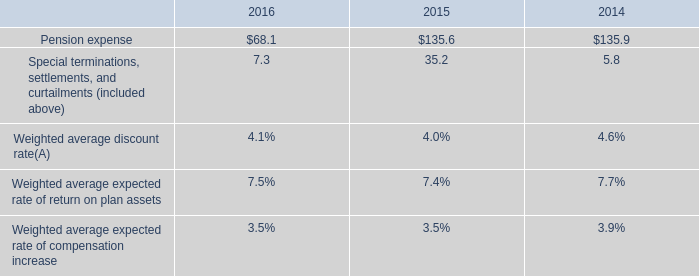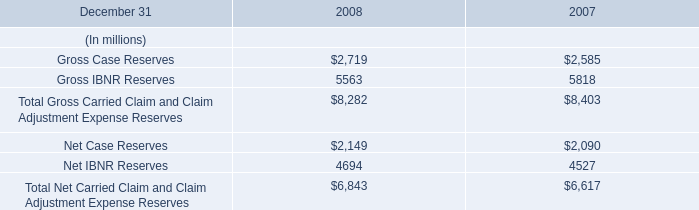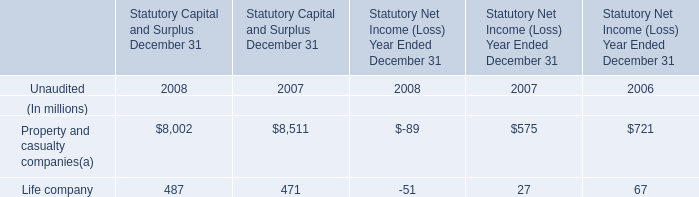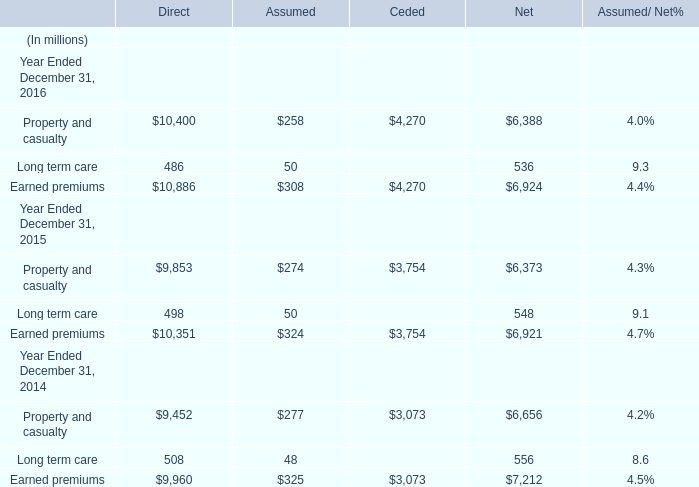What is the average amount of Net Case Reserves of 2007, and Property and casualty Year Ended December 31, 2015 of Direct ? 
Computations: ((2090.0 + 9853.0) / 2)
Answer: 5971.5. 